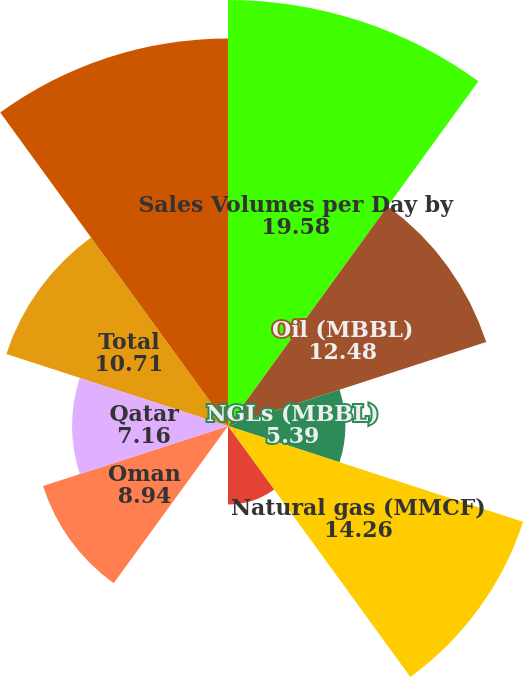Convert chart. <chart><loc_0><loc_0><loc_500><loc_500><pie_chart><fcel>Sales Volumes per Day by<fcel>Oil (MBBL)<fcel>NGLs (MBBL)<fcel>Natural gas (MMCF)<fcel>Al Hosn Gas<fcel>Dolphin<fcel>Oman<fcel>Qatar<fcel>Total<fcel>Total Sales Volumes (MBOE) (a)<nl><fcel>19.58%<fcel>12.48%<fcel>5.39%<fcel>14.26%<fcel>3.61%<fcel>0.06%<fcel>8.94%<fcel>7.16%<fcel>10.71%<fcel>17.81%<nl></chart> 